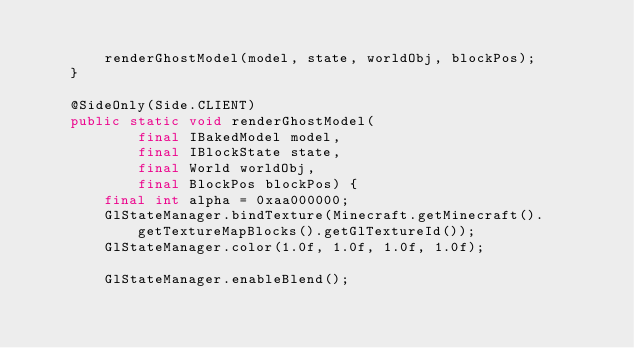<code> <loc_0><loc_0><loc_500><loc_500><_Java_>
        renderGhostModel(model, state, worldObj, blockPos);
    }

    @SideOnly(Side.CLIENT)
    public static void renderGhostModel(
            final IBakedModel model,
            final IBlockState state,
            final World worldObj,
            final BlockPos blockPos) {
        final int alpha = 0xaa000000;
        GlStateManager.bindTexture(Minecraft.getMinecraft().getTextureMapBlocks().getGlTextureId());
        GlStateManager.color(1.0f, 1.0f, 1.0f, 1.0f);

        GlStateManager.enableBlend();</code> 